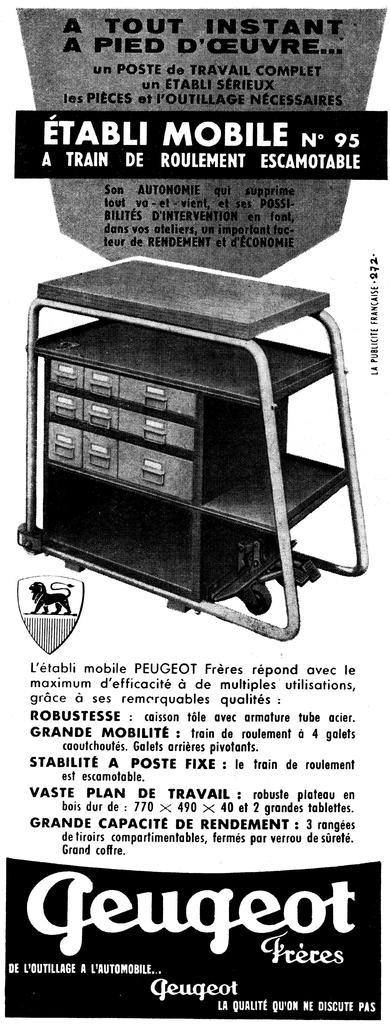What number is the trolley?
Offer a very short reply. 95. What brand of trolley is this?
Your answer should be compact. Geugeot. 